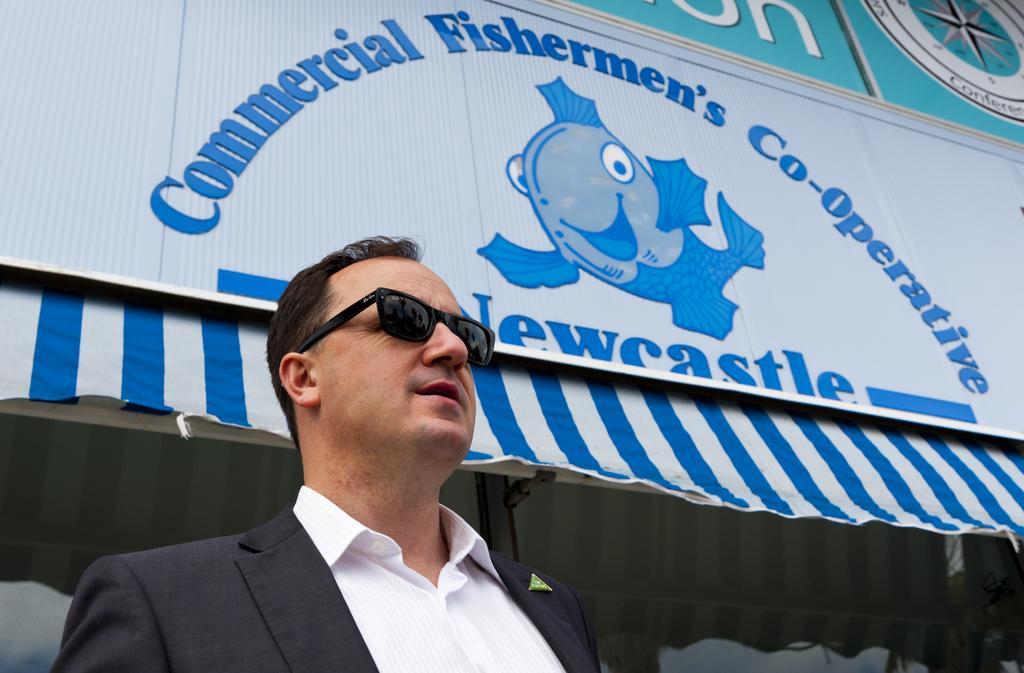In one or two sentences, can you explain what this image depicts? In this image we can see a man and an advertisement on the tent. 